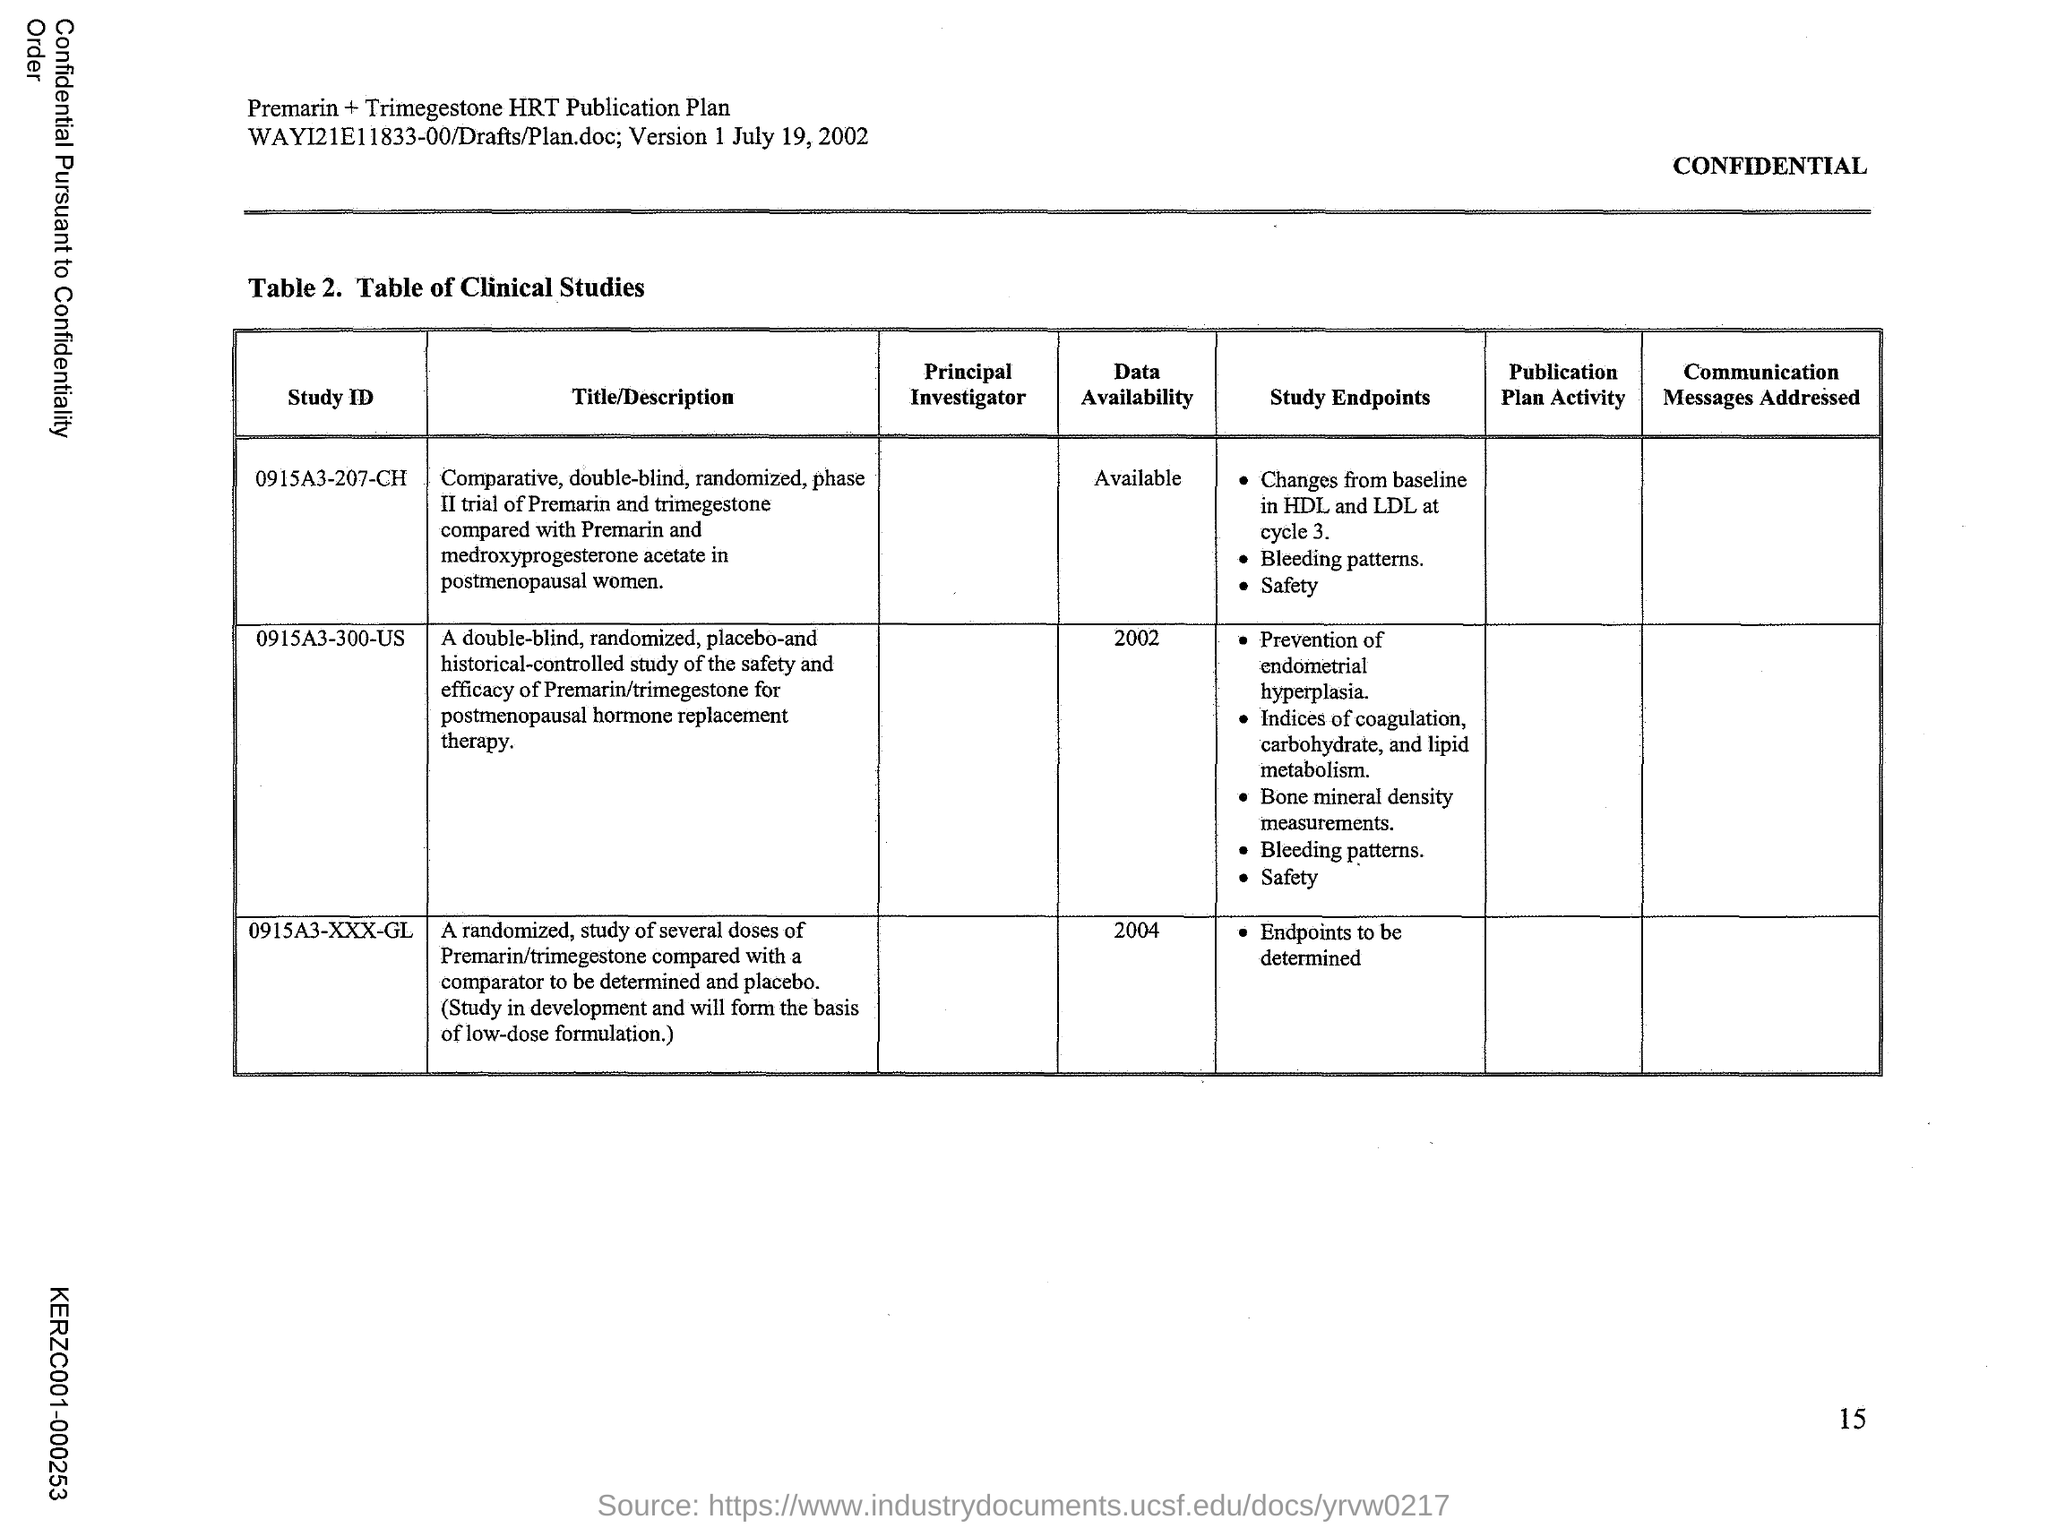What does Table 2. in this document represent?
Your response must be concise. Table of Clinical Studies. 